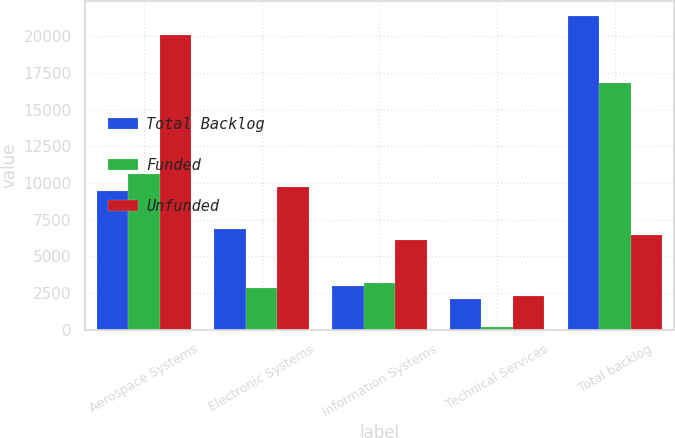Convert chart. <chart><loc_0><loc_0><loc_500><loc_500><stacked_bar_chart><ecel><fcel>Aerospace Systems<fcel>Electronic Systems<fcel>Information Systems<fcel>Technical Services<fcel>Total backlog<nl><fcel>Total Backlog<fcel>9438<fcel>6845<fcel>2963<fcel>2127<fcel>21373<nl><fcel>Funded<fcel>10625<fcel>2870<fcel>3152<fcel>179<fcel>16826<nl><fcel>Unfunded<fcel>20063<fcel>9715<fcel>6115<fcel>2306<fcel>6480<nl></chart> 